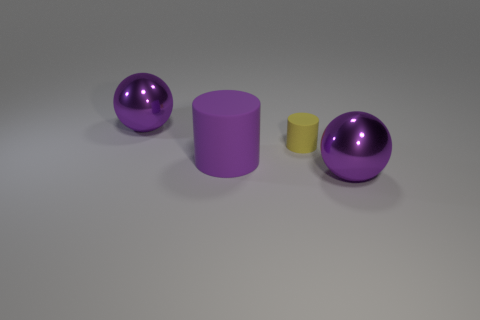Is there any other thing that has the same size as the yellow matte cylinder?
Your answer should be compact. No. Do the large purple shiny object behind the large purple matte cylinder and the metal thing that is right of the purple rubber cylinder have the same shape?
Provide a short and direct response. Yes. What number of objects are tiny red objects or purple metallic things that are on the left side of the purple cylinder?
Keep it short and to the point. 1. What number of other objects are there of the same size as the purple rubber object?
Provide a succinct answer. 2. Is the large ball that is behind the yellow rubber object made of the same material as the yellow cylinder right of the purple matte object?
Ensure brevity in your answer.  No. There is a yellow rubber cylinder; how many big purple objects are behind it?
Offer a very short reply. 1. What number of blue things are either large rubber cylinders or rubber things?
Your response must be concise. 0. There is a thing that is both behind the big purple cylinder and to the right of the large purple matte cylinder; what shape is it?
Your response must be concise. Cylinder. Is the size of the shiny sphere behind the large cylinder the same as the rubber cylinder on the left side of the tiny object?
Keep it short and to the point. Yes. There is a purple ball that is in front of the purple metallic ball that is behind the ball on the right side of the big purple rubber object; what is its size?
Give a very brief answer. Large. 